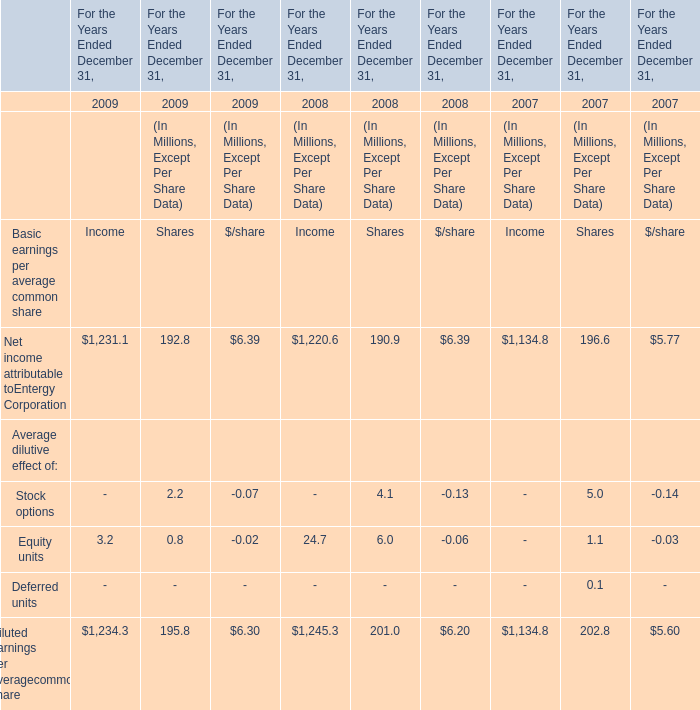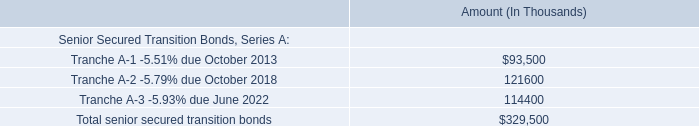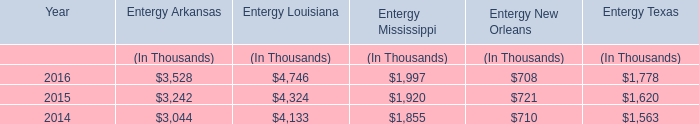what are the payments for the next three years on the entergy new orleans storm recovery bonds ( in millions? ) 
Computations: (10.6 + 11)
Answer: 21.6. 